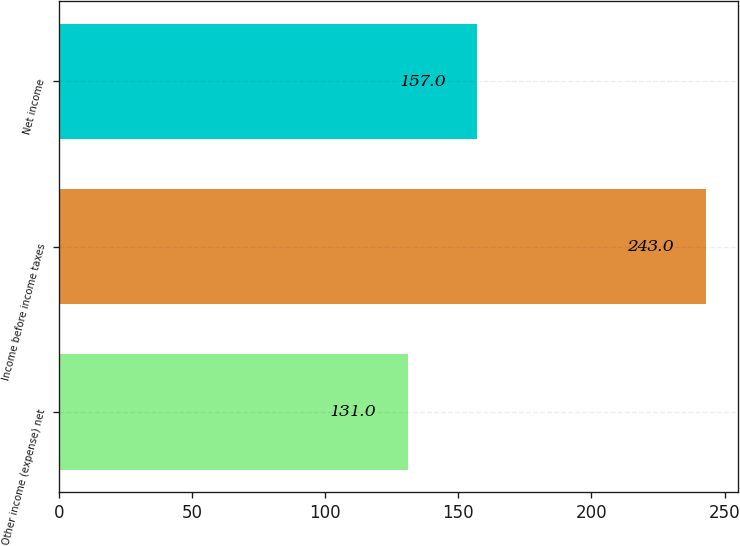Convert chart. <chart><loc_0><loc_0><loc_500><loc_500><bar_chart><fcel>Other income (expense) net<fcel>Income before income taxes<fcel>Net income<nl><fcel>131<fcel>243<fcel>157<nl></chart> 